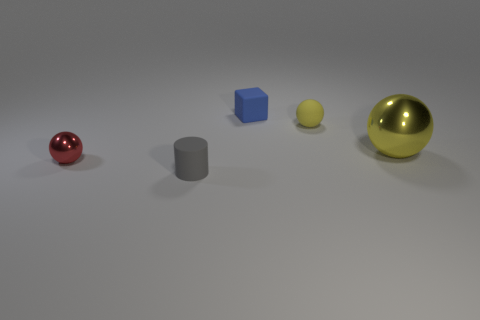The object in front of the metal thing on the left side of the tiny yellow object is what shape?
Provide a short and direct response. Cylinder. Are there fewer small metallic balls that are behind the small red metal ball than yellow rubber blocks?
Your response must be concise. No. What shape is the red thing?
Your answer should be very brief. Sphere. There is a metal ball to the left of the block; how big is it?
Your answer should be very brief. Small. What color is the rubber block that is the same size as the red ball?
Offer a terse response. Blue. Are there any objects that have the same color as the matte sphere?
Make the answer very short. Yes. Is the number of gray objects that are behind the tiny blue matte thing less than the number of small blue things behind the small gray thing?
Provide a short and direct response. Yes. There is a ball that is in front of the small yellow matte object and behind the tiny red ball; what is its material?
Keep it short and to the point. Metal. Do the yellow metal object and the shiny object that is left of the small yellow ball have the same shape?
Offer a very short reply. Yes. How many other things are there of the same size as the blue matte cube?
Your answer should be compact. 3. 